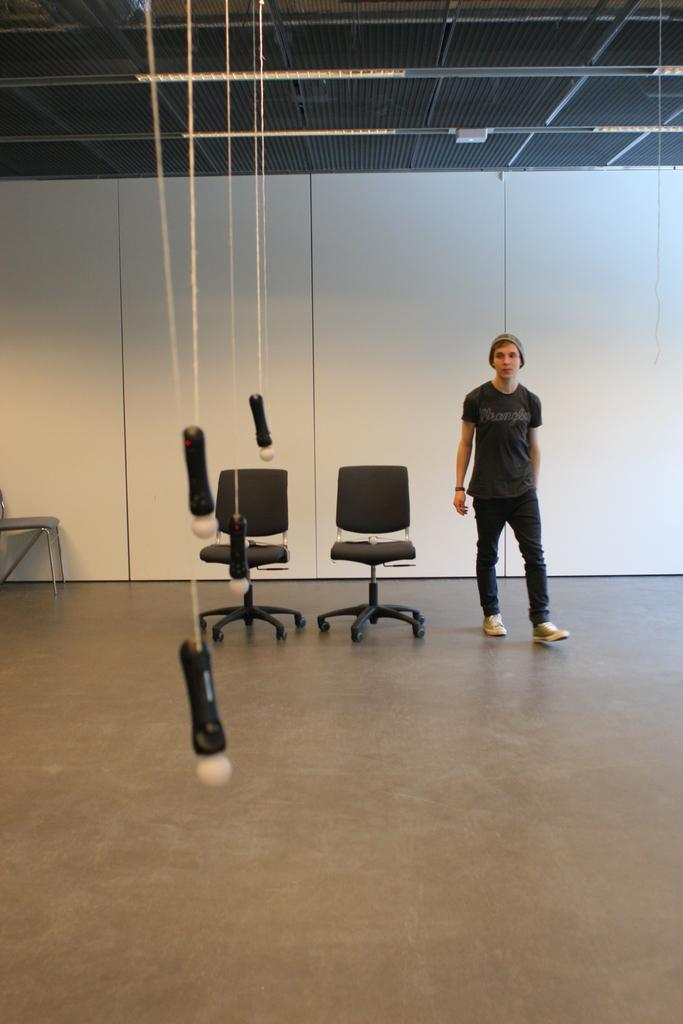What is the main subject of the image? There is a person in the image. What is the person wearing? The person is wearing a black dress. What is the person doing in the image? The person is standing. What objects are near the person? There are two black chairs beside the person. What can be seen in front of the person? There are ropes tied to an object in front of the person. How does the person help the car stop in the image? There is no car present in the image, and therefore no need for the person to help it stop. 